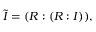<formula> <loc_0><loc_0><loc_500><loc_500>{ \tilde { I } } = ( R \colon ( R \colon I ) ) ,</formula> 